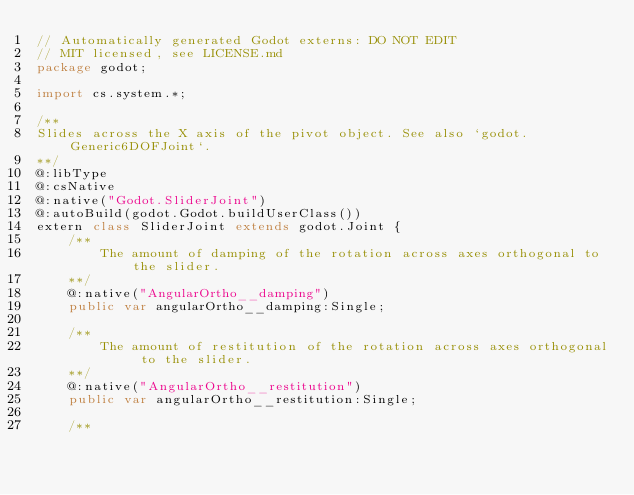<code> <loc_0><loc_0><loc_500><loc_500><_Haxe_>// Automatically generated Godot externs: DO NOT EDIT
// MIT licensed, see LICENSE.md
package godot;

import cs.system.*;

/**
Slides across the X axis of the pivot object. See also `godot.Generic6DOFJoint`.
**/
@:libType
@:csNative
@:native("Godot.SliderJoint")
@:autoBuild(godot.Godot.buildUserClass())
extern class SliderJoint extends godot.Joint {
	/**		
		The amount of damping of the rotation across axes orthogonal to the slider.
	**/
	@:native("AngularOrtho__damping")
	public var angularOrtho__damping:Single;

	/**		
		The amount of restitution of the rotation across axes orthogonal to the slider.
	**/
	@:native("AngularOrtho__restitution")
	public var angularOrtho__restitution:Single;

	/**		</code> 